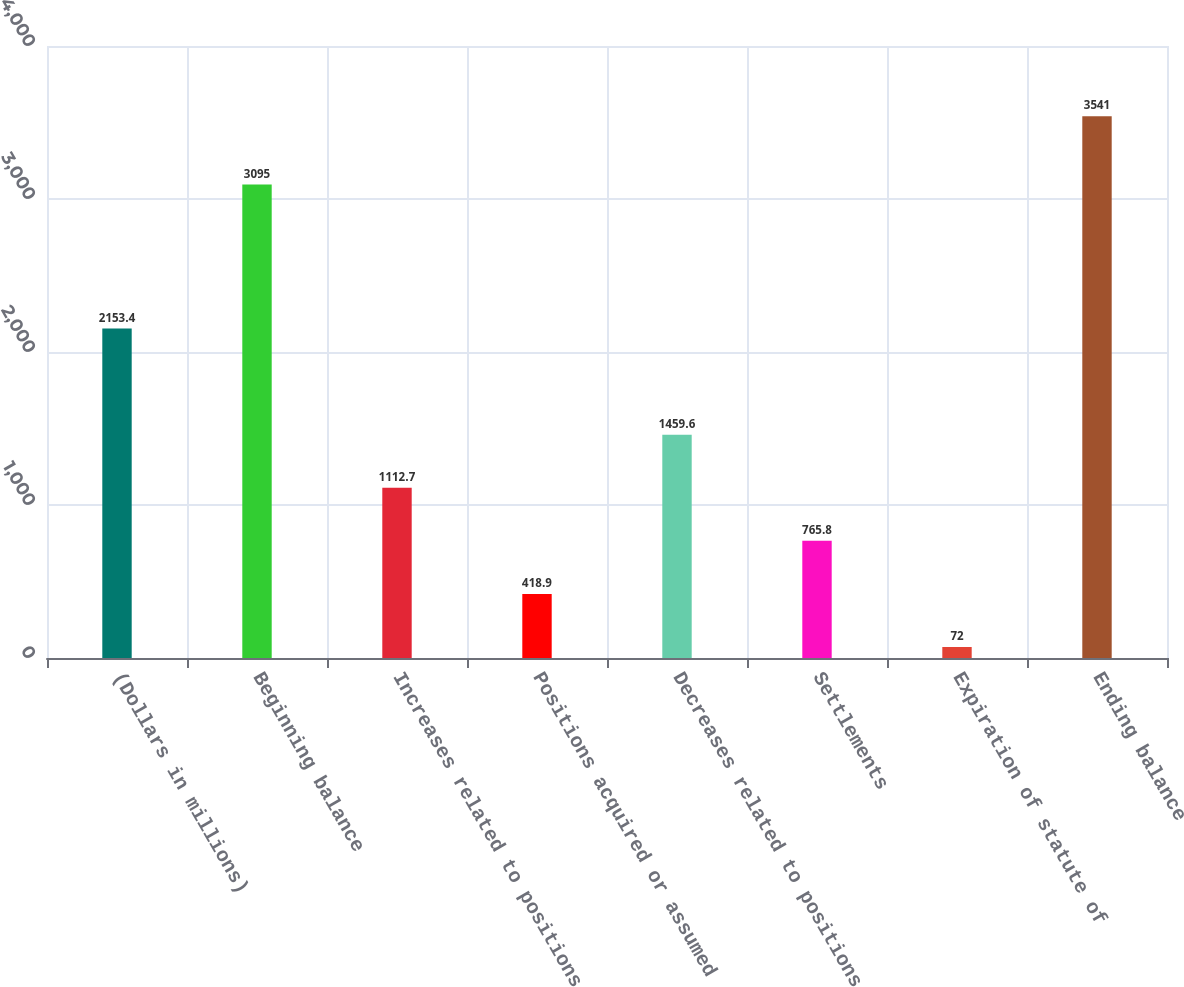Convert chart. <chart><loc_0><loc_0><loc_500><loc_500><bar_chart><fcel>(Dollars in millions)<fcel>Beginning balance<fcel>Increases related to positions<fcel>Positions acquired or assumed<fcel>Decreases related to positions<fcel>Settlements<fcel>Expiration of statute of<fcel>Ending balance<nl><fcel>2153.4<fcel>3095<fcel>1112.7<fcel>418.9<fcel>1459.6<fcel>765.8<fcel>72<fcel>3541<nl></chart> 